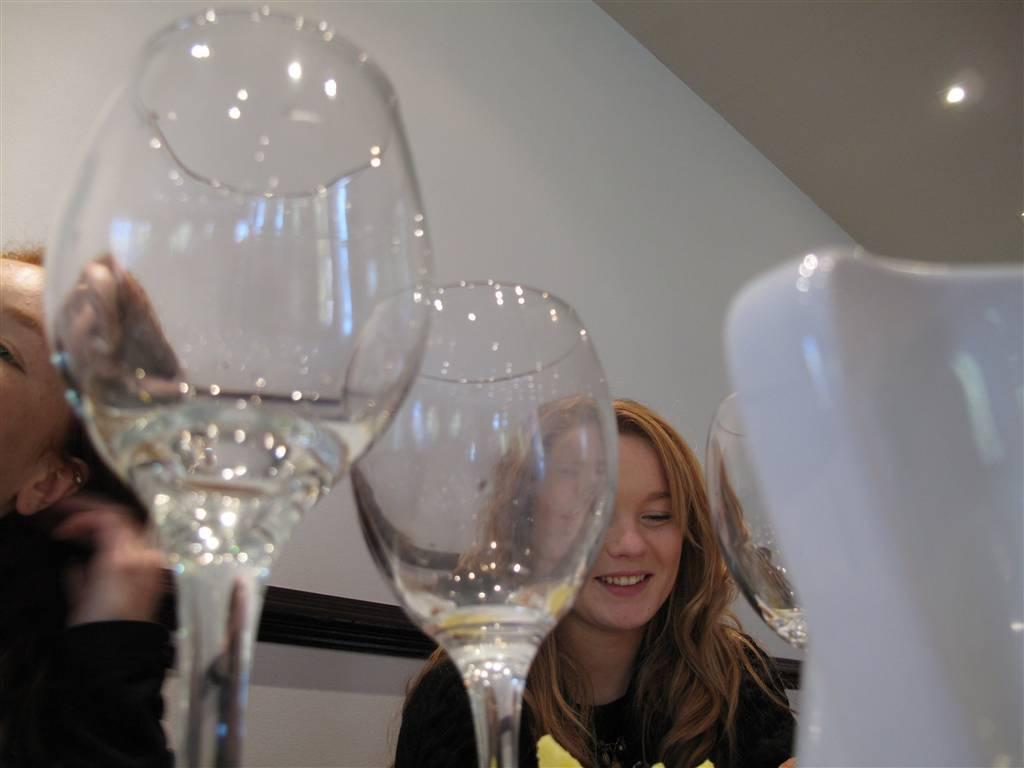What objects can be seen in the image? There are glasses in the image. How many people are present in the image? There are two persons in the image. Can you describe the woman in the image? One of the persons is a woman who is smiling. What can be seen in the background of the image? There is a wall and a light in the background of the image. What type of crate is being used for the meal in the image? There is no crate or meal present in the image. What is the purpose of the meeting in the image? There is no meeting depicted in the image. 